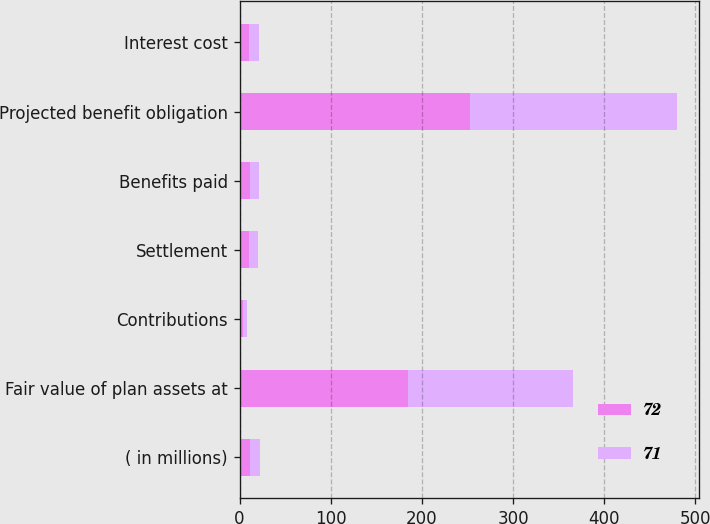<chart> <loc_0><loc_0><loc_500><loc_500><stacked_bar_chart><ecel><fcel>( in millions)<fcel>Fair value of plan assets at<fcel>Contributions<fcel>Settlement<fcel>Benefits paid<fcel>Projected benefit obligation<fcel>Interest cost<nl><fcel>72<fcel>11<fcel>185<fcel>4<fcel>10<fcel>11<fcel>253<fcel>10<nl><fcel>71<fcel>11<fcel>181<fcel>4<fcel>10<fcel>10<fcel>227<fcel>11<nl></chart> 